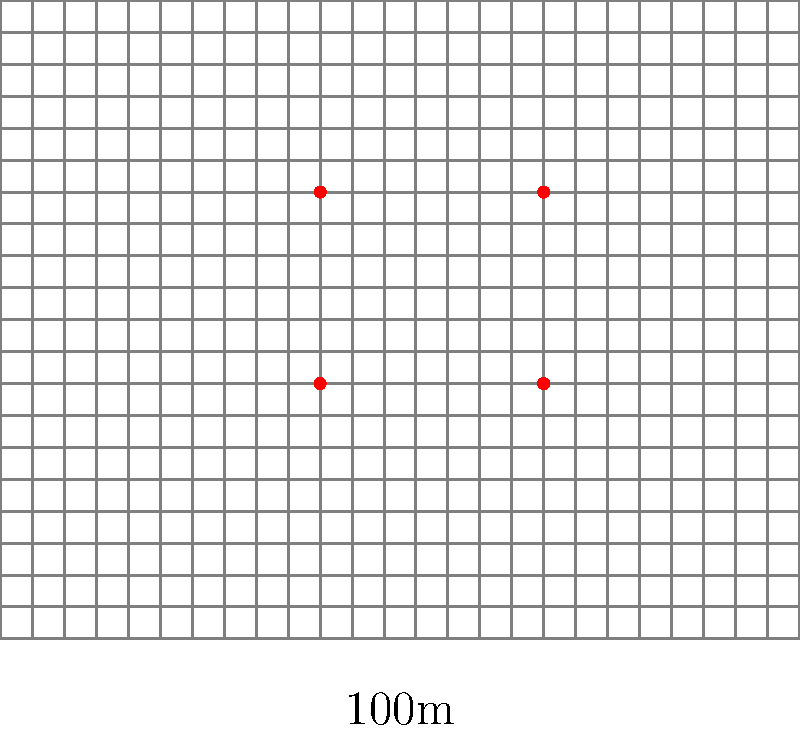A rectangular field measures 100m by 80m and is divided into a grid of 4m x 4m squares. Motion-activated deterrents are placed at the intersections of grid lines. If the effective range of each deterrent is 20m in all directions, what is the minimum number of deterrents needed to cover the entire field? The diagram shows an example placement of 4 deterrents (red dots). Calculate the optimal spacing and arrangement to minimize the number of deterrents while ensuring complete coverage. To solve this problem, we'll follow these steps:

1. Calculate the coverage area of each deterrent:
   The effective range is 20m in all directions, so each deterrent covers a circular area with a radius of 20m.
   Area of coverage = $\pi r^2 = \pi \cdot 20^2 = 1256.64$ m²

2. Determine the optimal spacing between deterrents:
   To ensure complete coverage with minimal overlap, we should space the deterrents $2r\sqrt{2}$ apart in a square grid pattern.
   Optimal spacing = $2 \cdot 20 \cdot \sqrt{2} = 56.57$ m

3. Calculate the number of deterrents needed along the length and width:
   Length: $100 \text{ m} \div 56.57 \text{ m} \approx 1.77$ (round up to 2)
   Width: $80 \text{ m} \div 56.57 \text{ m} \approx 1.41$ (round up to 2)

4. Multiply the number of deterrents needed in each direction:
   Total deterrents = $2 \times 2 = 4$

5. Verify coverage:
   With 4 deterrents placed optimally, we can cover:
   $4 \times 1256.64 \text{ m}² = 5026.56 \text{ m}²$
   Field area: $100 \text{ m} \times 80 \text{ m} = 8000 \text{ m}²$

   The coverage is sufficient because the circular areas overlap, ensuring complete coverage of the rectangular field.

Therefore, the minimum number of deterrents needed to cover the entire field is 4, placed at the corners of a 56.57m x 56.57m square grid within the field.
Answer: 4 deterrents 